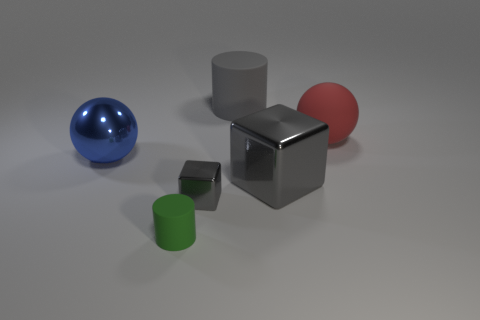What can you infer about the setting from the image? The setting appears to be an artificial, possibly virtual environment, characterized by a neutral, non-descript grey background. The absence of any distinguishable features or context implies that the purpose of the image is to focus on the objects and their material properties rather than the surroundings. 